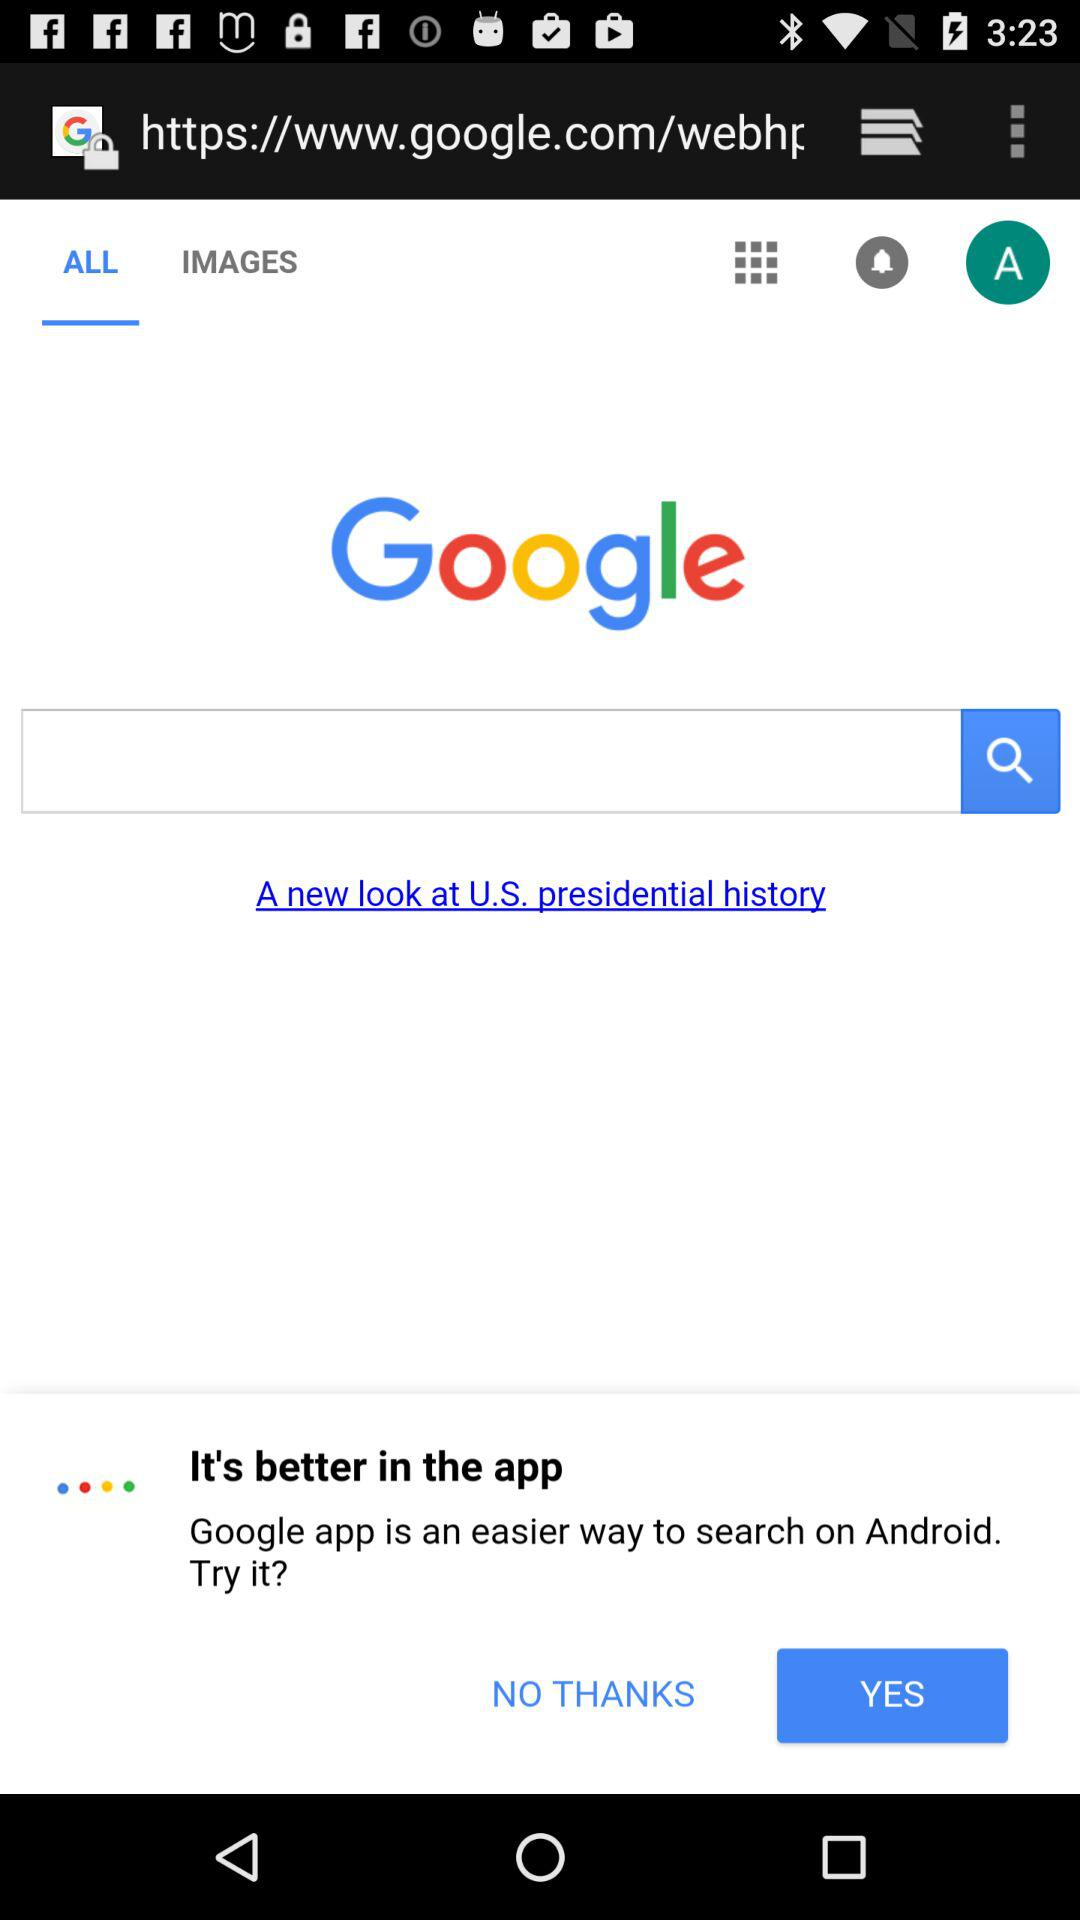Which tab am I on? You are on the "ALL" tab. 